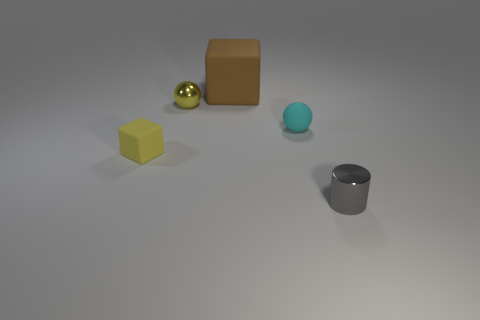Add 3 yellow rubber cylinders. How many objects exist? 8 Subtract all cylinders. How many objects are left? 4 Subtract 0 red balls. How many objects are left? 5 Subtract all yellow objects. Subtract all tiny gray objects. How many objects are left? 2 Add 1 small yellow matte blocks. How many small yellow matte blocks are left? 2 Add 2 large brown balls. How many large brown balls exist? 2 